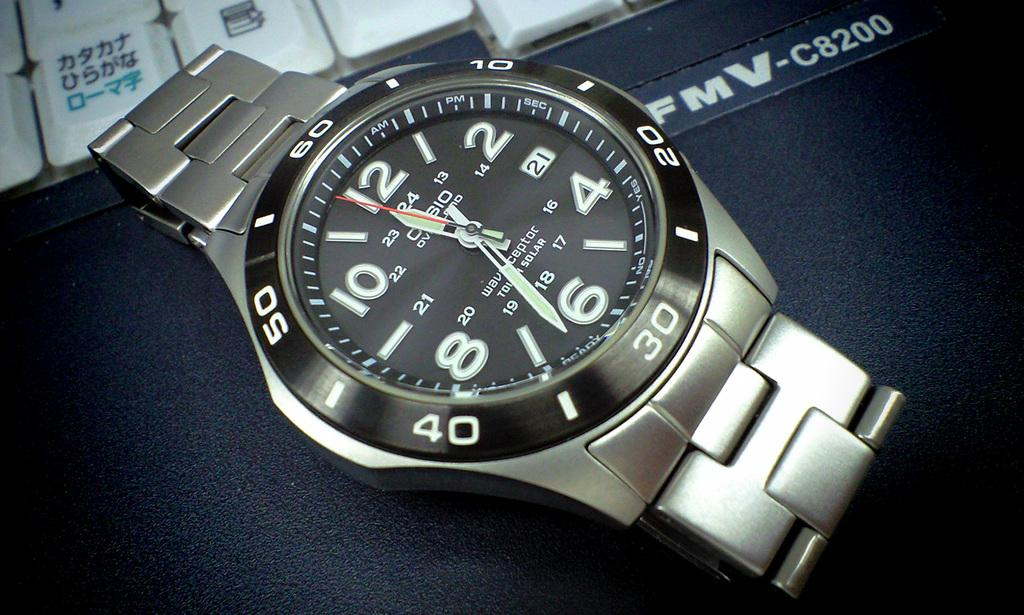<image>
Render a clear and concise summary of the photo. A silver and black faced watch has the time of 11:32. 